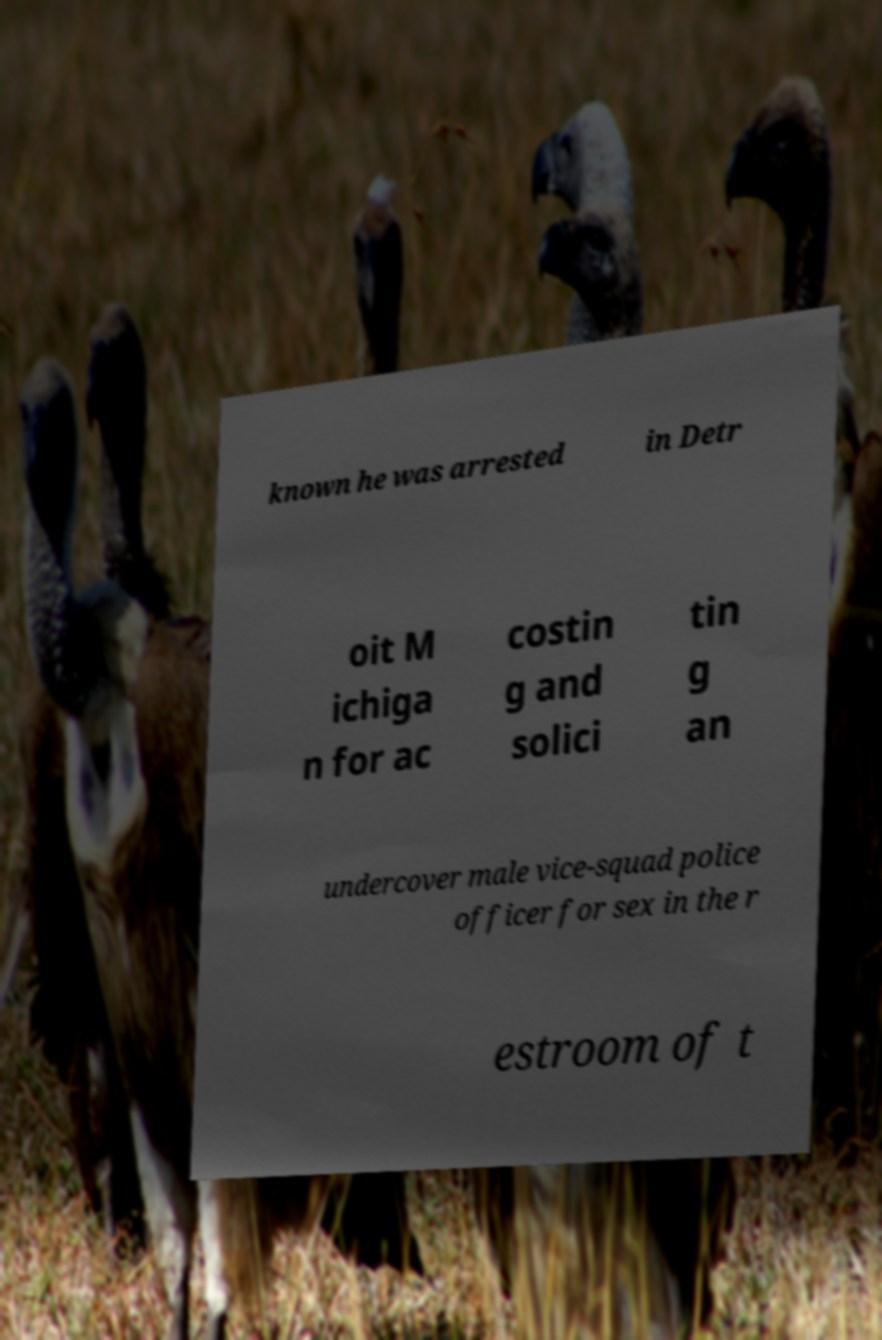For documentation purposes, I need the text within this image transcribed. Could you provide that? known he was arrested in Detr oit M ichiga n for ac costin g and solici tin g an undercover male vice-squad police officer for sex in the r estroom of t 